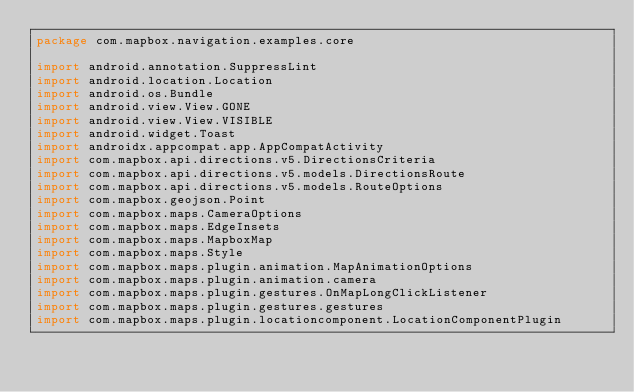Convert code to text. <code><loc_0><loc_0><loc_500><loc_500><_Kotlin_>package com.mapbox.navigation.examples.core

import android.annotation.SuppressLint
import android.location.Location
import android.os.Bundle
import android.view.View.GONE
import android.view.View.VISIBLE
import android.widget.Toast
import androidx.appcompat.app.AppCompatActivity
import com.mapbox.api.directions.v5.DirectionsCriteria
import com.mapbox.api.directions.v5.models.DirectionsRoute
import com.mapbox.api.directions.v5.models.RouteOptions
import com.mapbox.geojson.Point
import com.mapbox.maps.CameraOptions
import com.mapbox.maps.EdgeInsets
import com.mapbox.maps.MapboxMap
import com.mapbox.maps.Style
import com.mapbox.maps.plugin.animation.MapAnimationOptions
import com.mapbox.maps.plugin.animation.camera
import com.mapbox.maps.plugin.gestures.OnMapLongClickListener
import com.mapbox.maps.plugin.gestures.gestures
import com.mapbox.maps.plugin.locationcomponent.LocationComponentPlugin</code> 